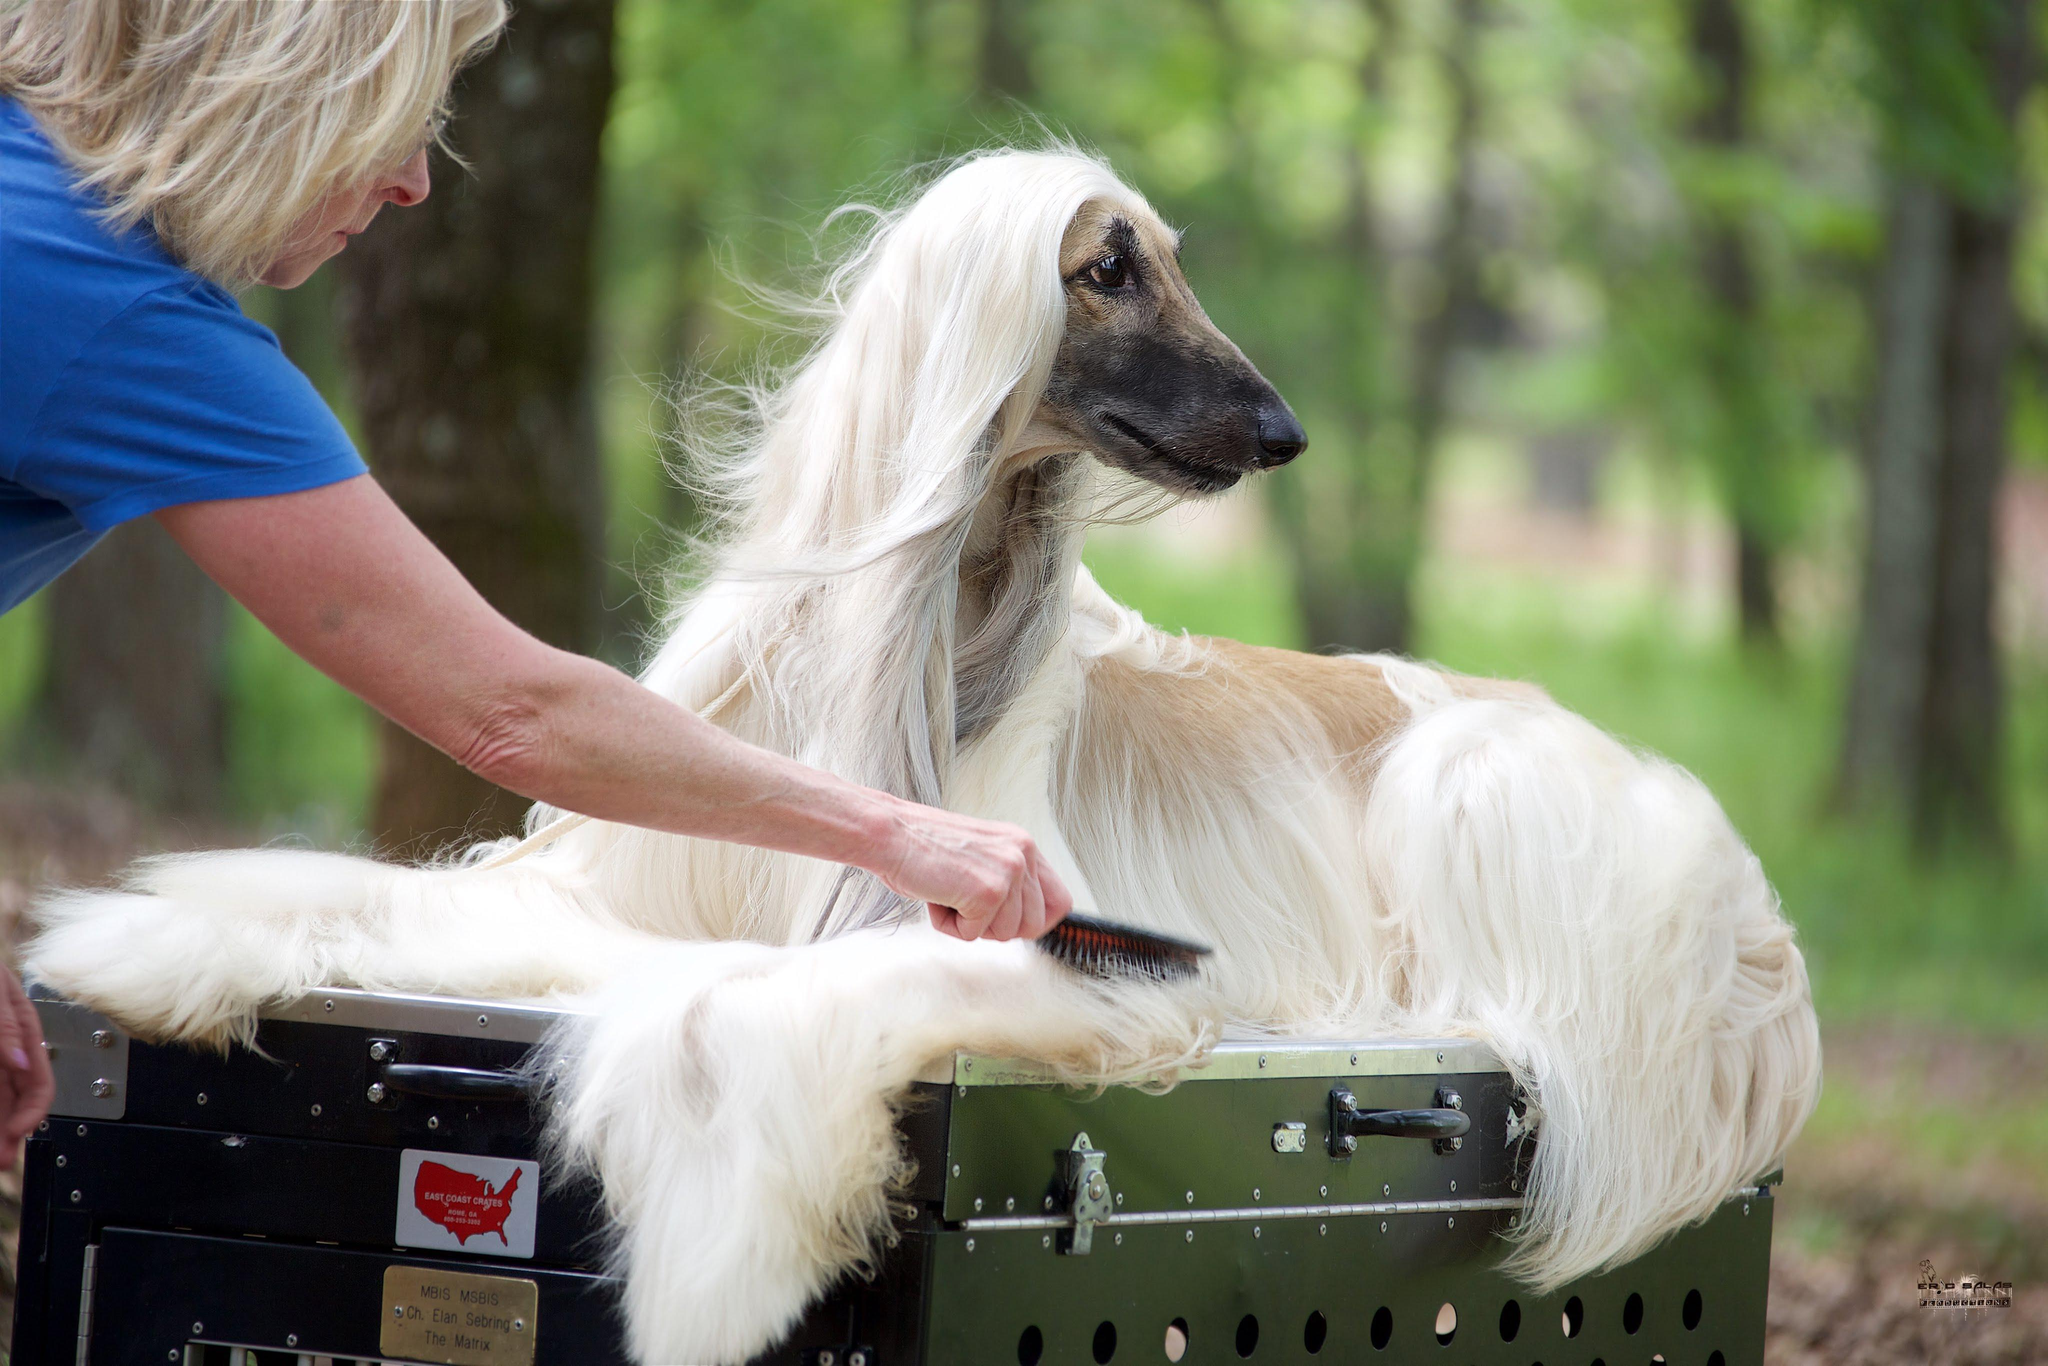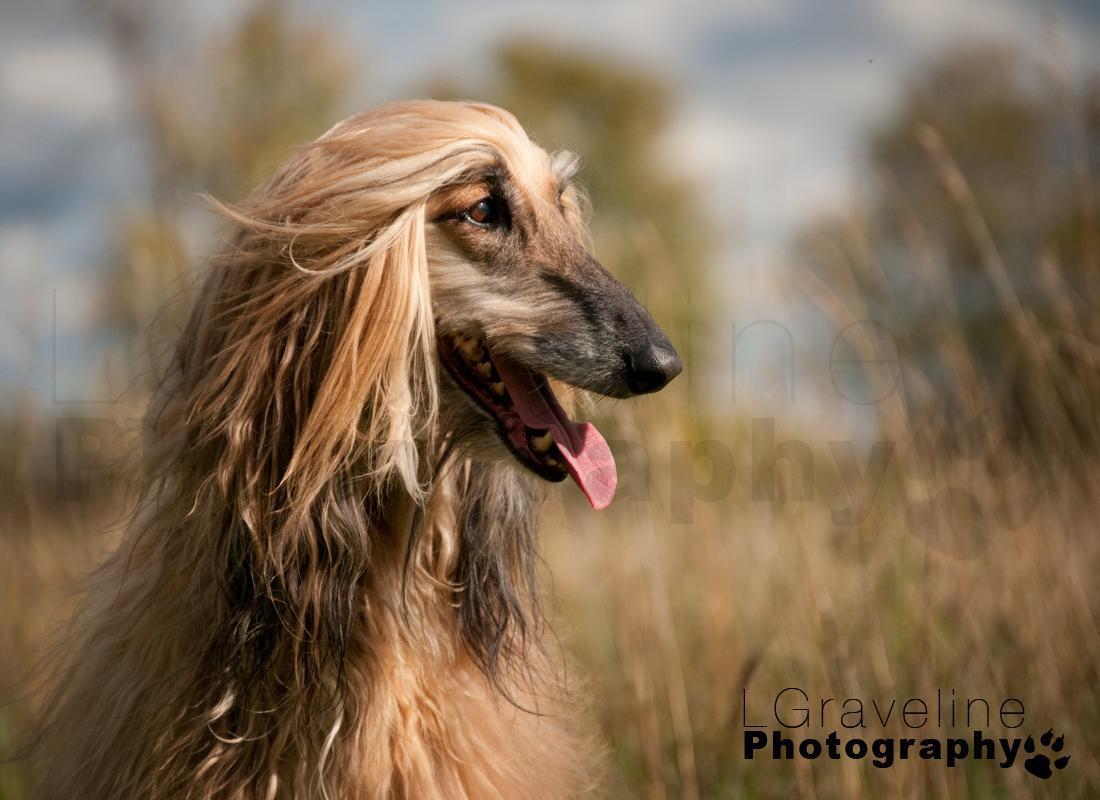The first image is the image on the left, the second image is the image on the right. Assess this claim about the two images: "A human's arm can be seen in one of the photos.". Correct or not? Answer yes or no. Yes. The first image is the image on the left, the second image is the image on the right. Evaluate the accuracy of this statement regarding the images: "There are two dogs facing each other in the image on the right.". Is it true? Answer yes or no. No. 